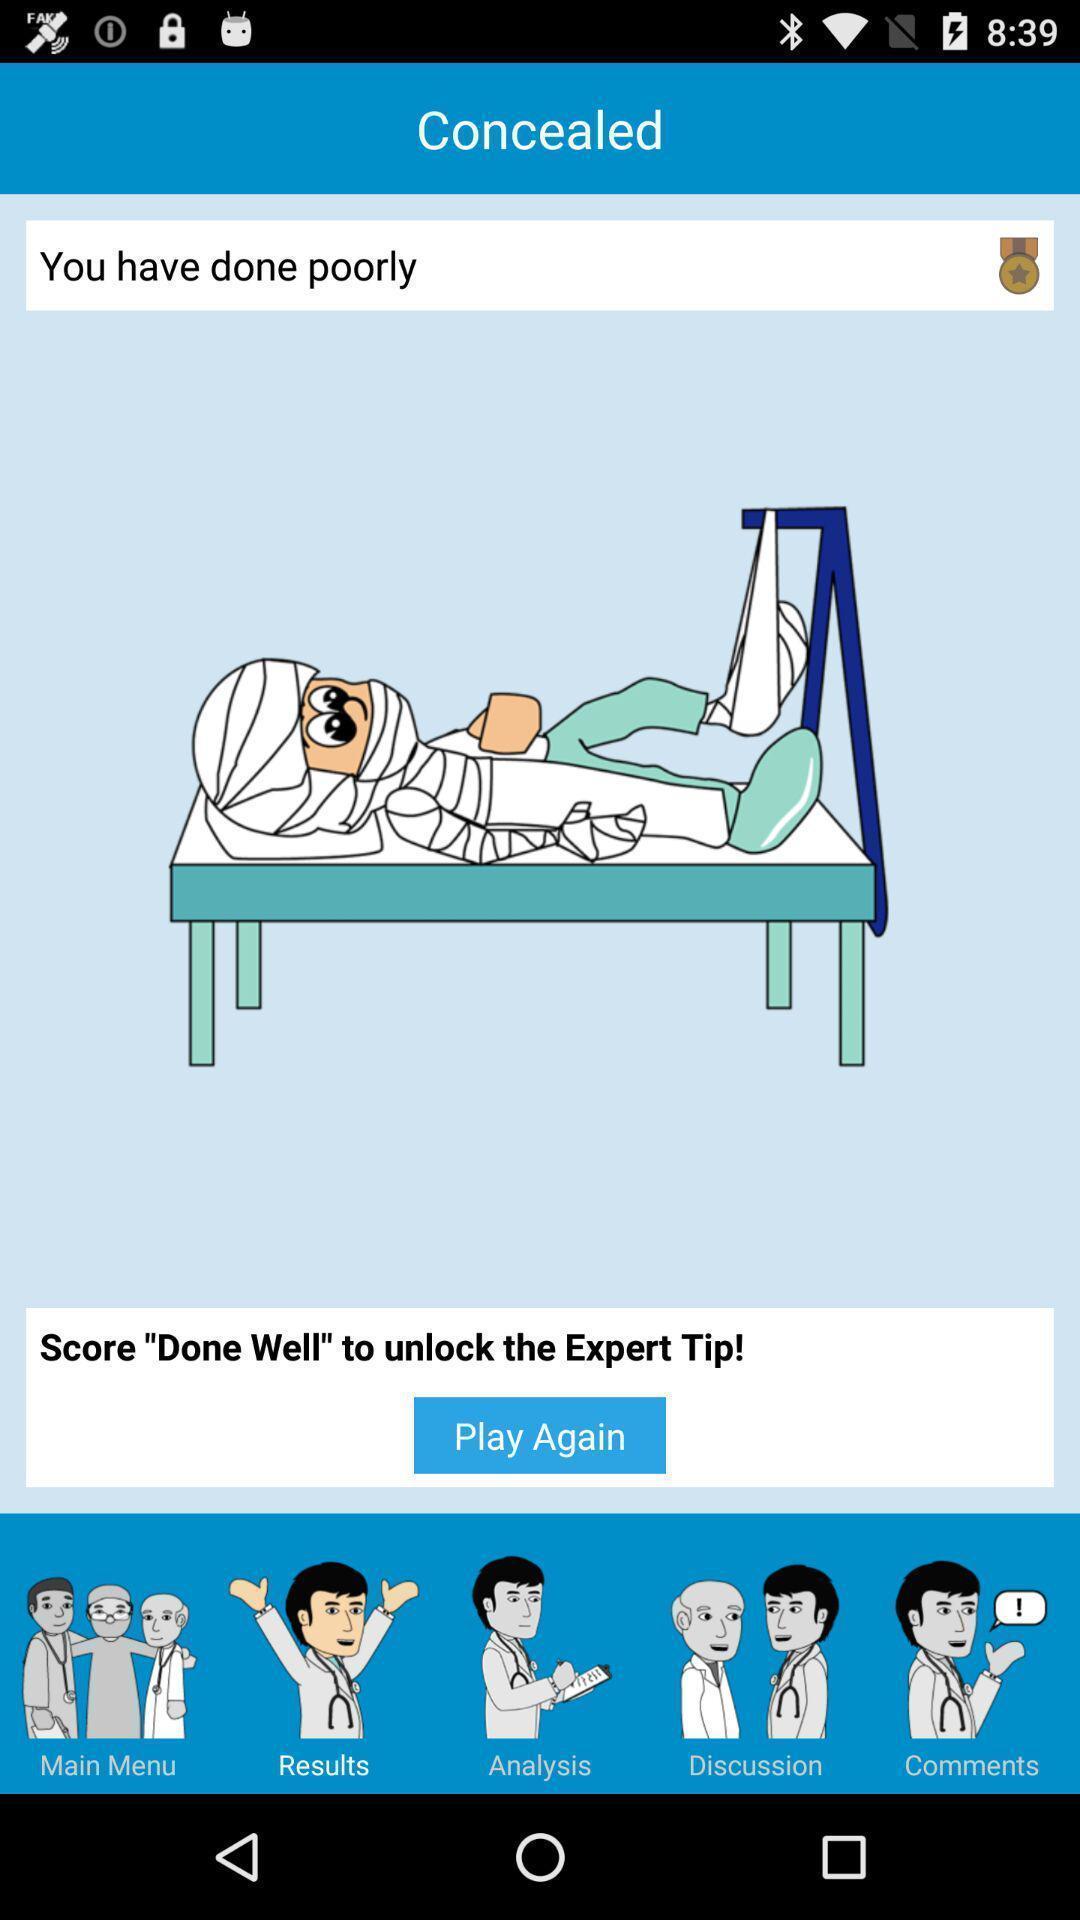Describe the visual elements of this screenshot. Page showing different options in doctor consultation app. 